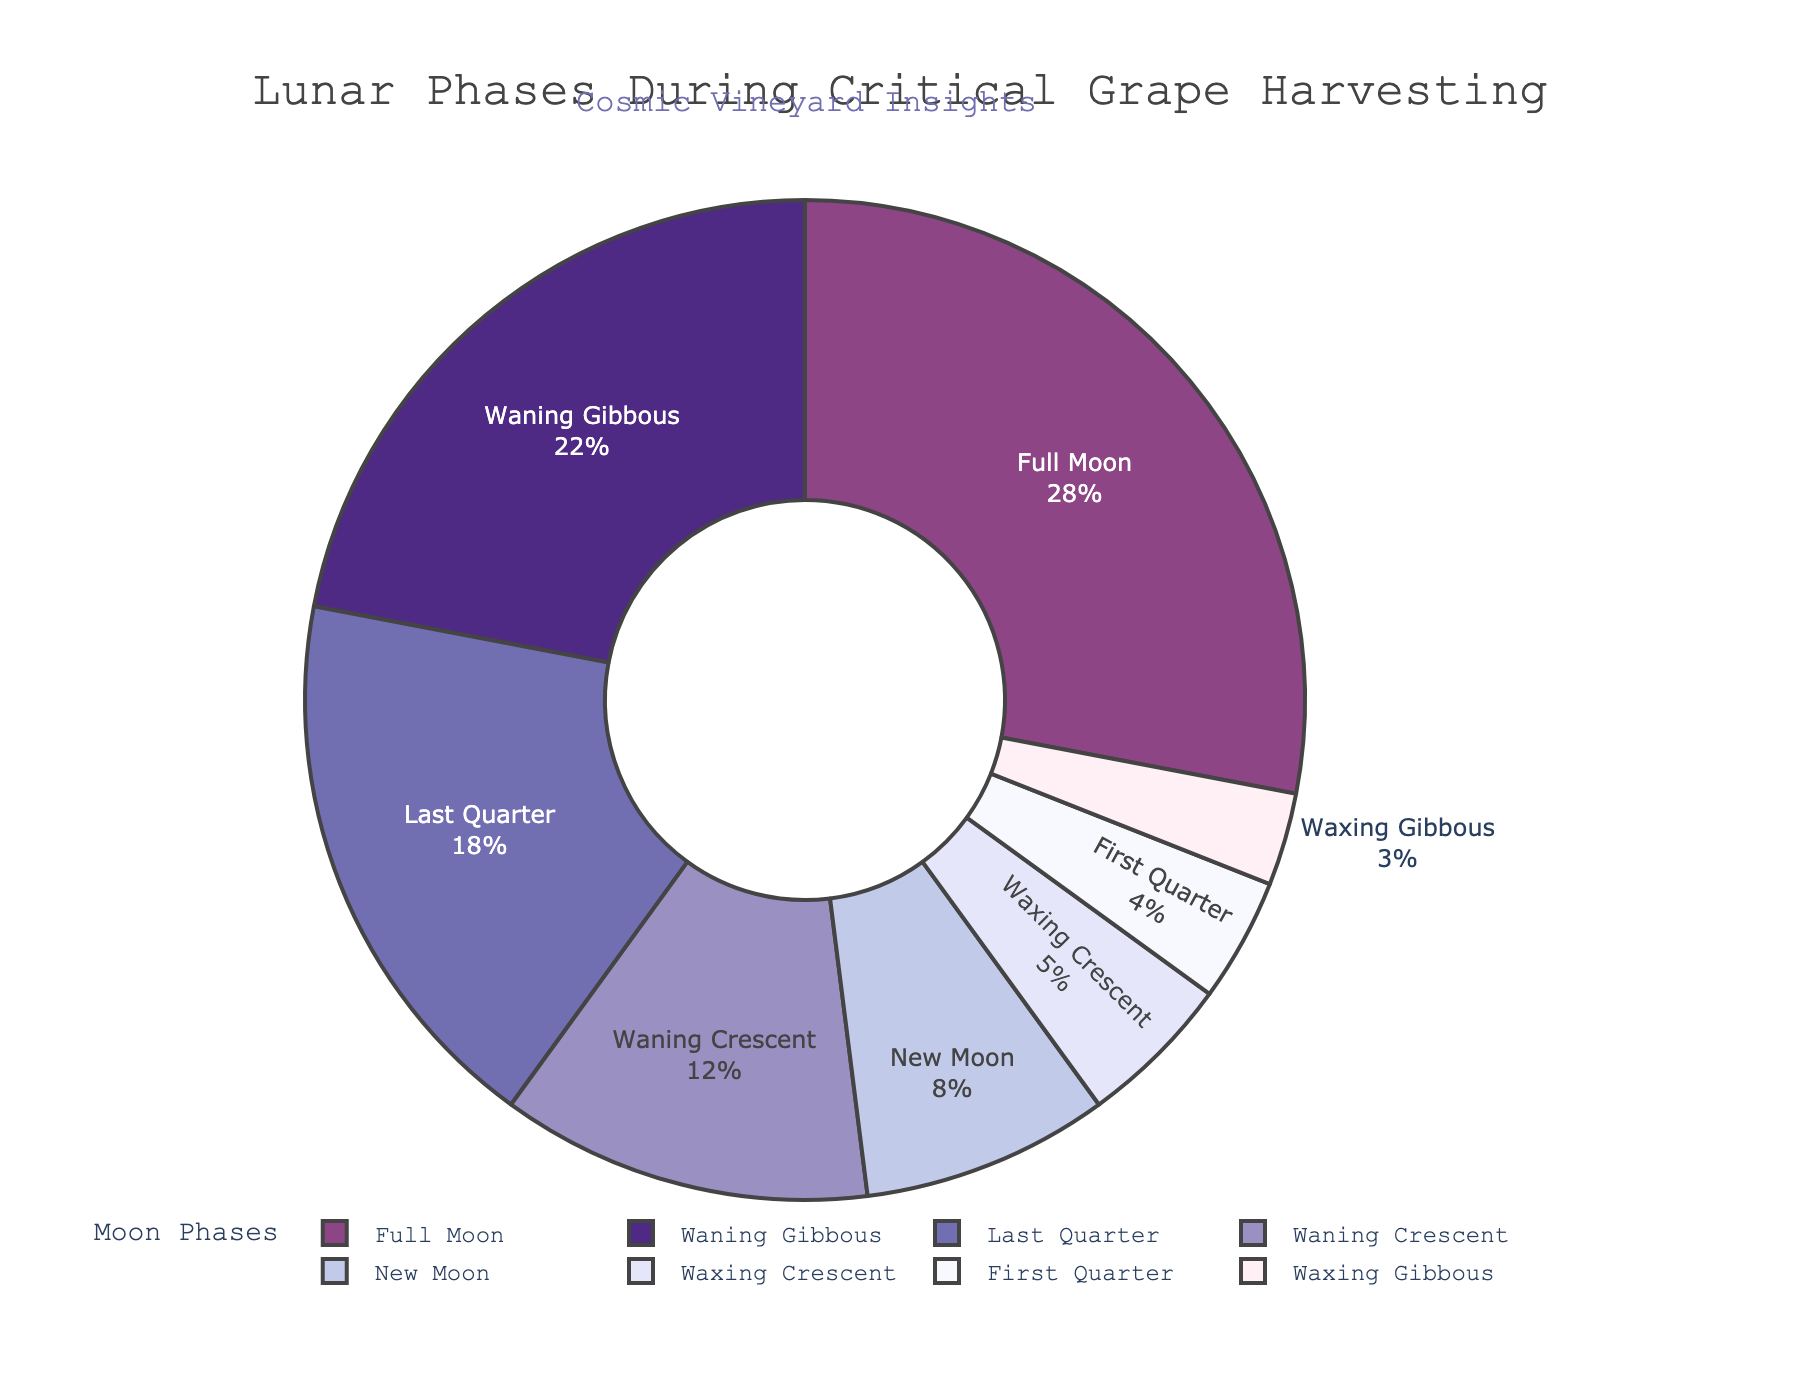How much percentage of critical grape harvesting happens during the Full Moon and Waning Gibbous combined? To find the combined percentage of Full Moon and Waning Gibbous, we sum their individual percentages: Full Moon (28%) + Waning Gibbous (22%) = 50%.
Answer: 50% Which moon phase corresponds to the smallest percentage of critical grape harvesting? By inspecting the pie chart, we observe that Waxing Gibbous has the smallest percentage at 3%.
Answer: Waxing Gibbous Is the percentage of harvesting during the Full Moon phase greater than the combined percentage of the First Quarter and Waxing Crescent phases? Full Moon phase harvesting is 28%. The combined percentage of First Quarter and Waxing Crescent is 4% + 5% = 9%. 28% is indeed greater than 9%.
Answer: Yes What is the difference between the percentage of harvesting during the Last Quarter and New Moon phases? The Last Quarter phase has 18% and the New Moon phase has 8%. The difference is: 18% - 8% = 10%.
Answer: 10% What is the combined percentage of harvesting during the three phases with the smallest percentages? The three smallest percentages belong to Waxing Gibbous (3%), First Quarter (4%), and Waxing Crescent (5%). The combined percentage is 3% + 4% + 5% = 12%.
Answer: 12% Which moon phase has the second highest percentage of harvesting, and what is that percentage? The Full Moon has the highest percentage at 28%, and the Waning Gibbous has the second highest at 22%.
Answer: Waning Gibbous, 22% What proportion of the total harvesting happens during the crescent phases (Waxing Crescent and Waning Crescent)? Waxing Crescent accounts for 5% and Waning Crescent for 12%. The combined proportion is: 5% + 12% = 17%.
Answer: 17% Is the sum of percentages of the Waning Gibbous and Last Quarter phases greater than 50%? The Waning Gibbous phase has 22% and the Last Quarter phase has 18%. The combined sum is: 22% + 18% = 40%, which is not greater than 50%.
Answer: No If we focus on Full Moon and New Moon phases, what is the combined percentage of harvesting occurring during these phases? The Full Moon phase accounts for 28% and the New Moon phase accounts for 8%. Their combined percentage is: 28% + 8% = 36%.
Answer: 36% Which phases have combined percentages equal or larger than the Full Moon phase alone? The Full Moon phase is 28%. Adding percentages for the top phases until we reach or exceed 28%, we get Waning Gibbous (22%) + Last Quarter (18%) = 40%, which exceeds 28%.
Answer: Waning Gibbous and Last Quarter 